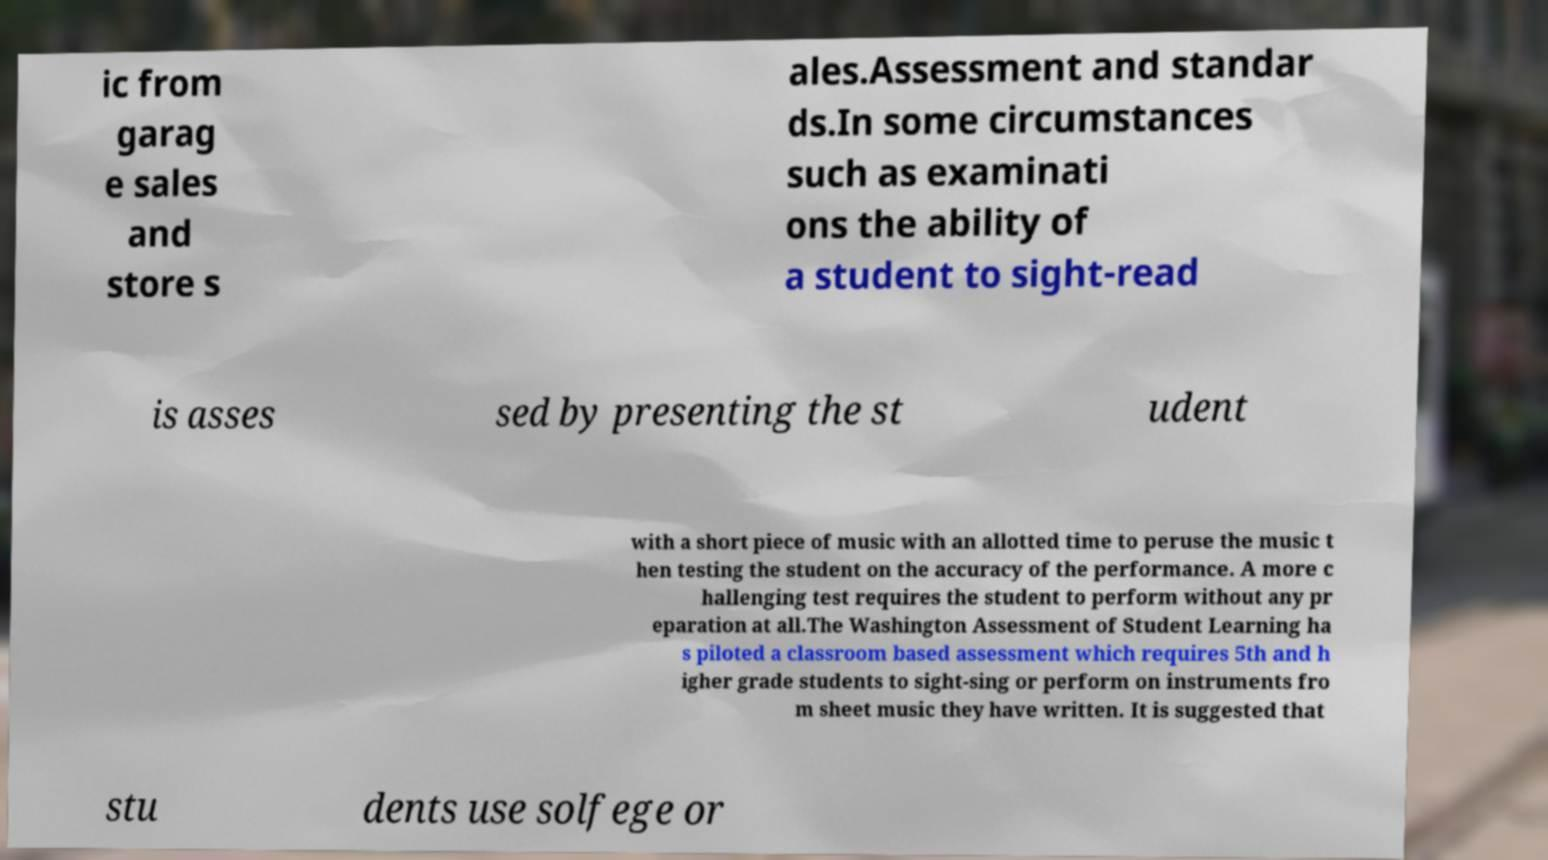For documentation purposes, I need the text within this image transcribed. Could you provide that? ic from garag e sales and store s ales.Assessment and standar ds.In some circumstances such as examinati ons the ability of a student to sight-read is asses sed by presenting the st udent with a short piece of music with an allotted time to peruse the music t hen testing the student on the accuracy of the performance. A more c hallenging test requires the student to perform without any pr eparation at all.The Washington Assessment of Student Learning ha s piloted a classroom based assessment which requires 5th and h igher grade students to sight-sing or perform on instruments fro m sheet music they have written. It is suggested that stu dents use solfege or 